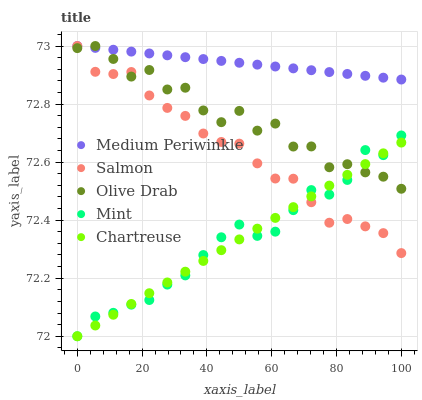Does Chartreuse have the minimum area under the curve?
Answer yes or no. Yes. Does Medium Periwinkle have the maximum area under the curve?
Answer yes or no. Yes. Does Medium Periwinkle have the minimum area under the curve?
Answer yes or no. No. Does Chartreuse have the maximum area under the curve?
Answer yes or no. No. Is Medium Periwinkle the smoothest?
Answer yes or no. Yes. Is Olive Drab the roughest?
Answer yes or no. Yes. Is Chartreuse the smoothest?
Answer yes or no. No. Is Chartreuse the roughest?
Answer yes or no. No. Does Chartreuse have the lowest value?
Answer yes or no. Yes. Does Medium Periwinkle have the lowest value?
Answer yes or no. No. Does Olive Drab have the highest value?
Answer yes or no. Yes. Does Chartreuse have the highest value?
Answer yes or no. No. Is Mint less than Medium Periwinkle?
Answer yes or no. Yes. Is Medium Periwinkle greater than Chartreuse?
Answer yes or no. Yes. Does Salmon intersect Mint?
Answer yes or no. Yes. Is Salmon less than Mint?
Answer yes or no. No. Is Salmon greater than Mint?
Answer yes or no. No. Does Mint intersect Medium Periwinkle?
Answer yes or no. No. 